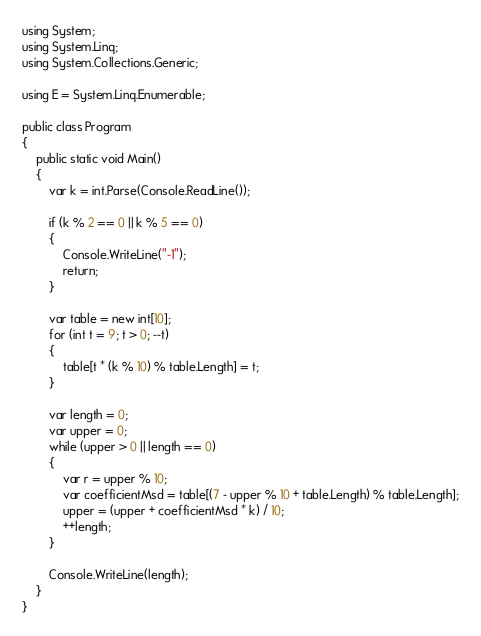Convert code to text. <code><loc_0><loc_0><loc_500><loc_500><_C#_>using System;
using System.Linq;
using System.Collections.Generic;

using E = System.Linq.Enumerable;

public class Program
{
    public static void Main()
    {
        var k = int.Parse(Console.ReadLine());

        if (k % 2 == 0 || k % 5 == 0)
        {
            Console.WriteLine("-1");
            return;
        }

        var table = new int[10];
        for (int t = 9; t > 0; --t)
        {
            table[t * (k % 10) % table.Length] = t;
        }

        var length = 0;
        var upper = 0;
        while (upper > 0 || length == 0)
        {
            var r = upper % 10;
            var coefficientMsd = table[(7 - upper % 10 + table.Length) % table.Length];
            upper = (upper + coefficientMsd * k) / 10;
            ++length;
        }

        Console.WriteLine(length);
    }
}
</code> 